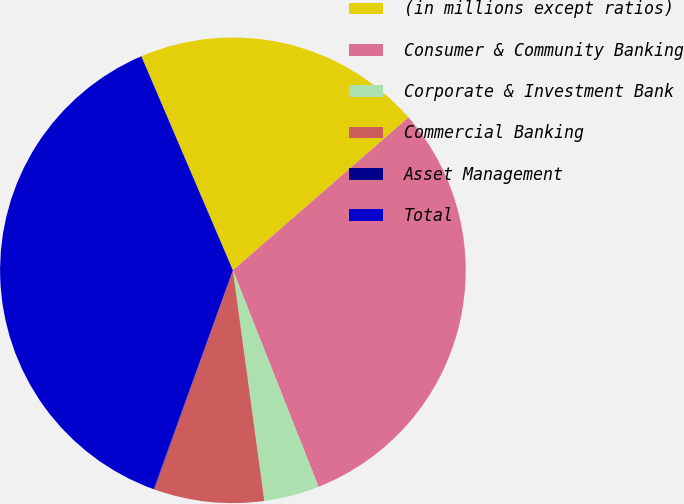Convert chart to OTSL. <chart><loc_0><loc_0><loc_500><loc_500><pie_chart><fcel>(in millions except ratios)<fcel>Consumer & Community Banking<fcel>Corporate & Investment Bank<fcel>Commercial Banking<fcel>Asset Management<fcel>Total<nl><fcel>20.03%<fcel>30.41%<fcel>3.84%<fcel>7.64%<fcel>0.04%<fcel>38.04%<nl></chart> 